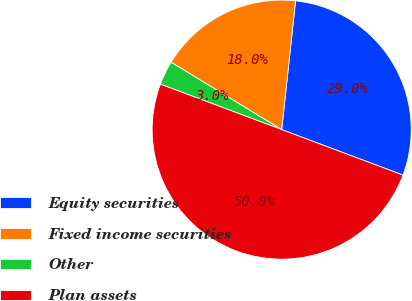Convert chart to OTSL. <chart><loc_0><loc_0><loc_500><loc_500><pie_chart><fcel>Equity securities<fcel>Fixed income securities<fcel>Other<fcel>Plan assets<nl><fcel>29.0%<fcel>18.0%<fcel>3.0%<fcel>50.0%<nl></chart> 